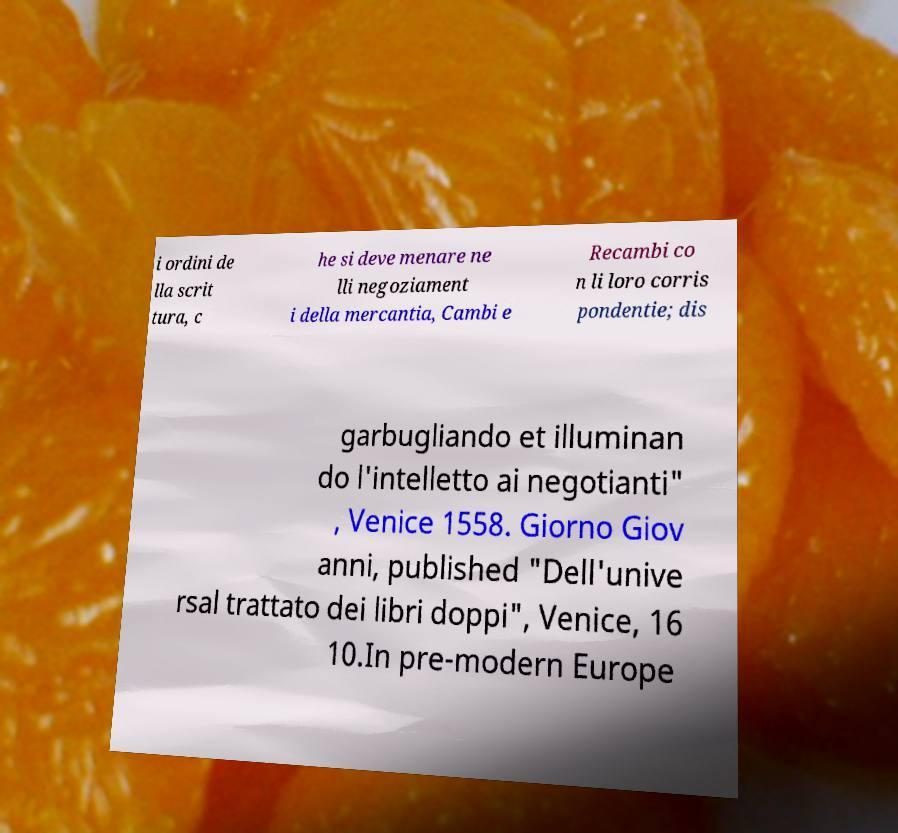I need the written content from this picture converted into text. Can you do that? i ordini de lla scrit tura, c he si deve menare ne lli negoziament i della mercantia, Cambi e Recambi co n li loro corris pondentie; dis garbugliando et illuminan do l'intelletto ai negotianti" , Venice 1558. Giorno Giov anni, published "Dell'unive rsal trattato dei libri doppi", Venice, 16 10.In pre-modern Europe 